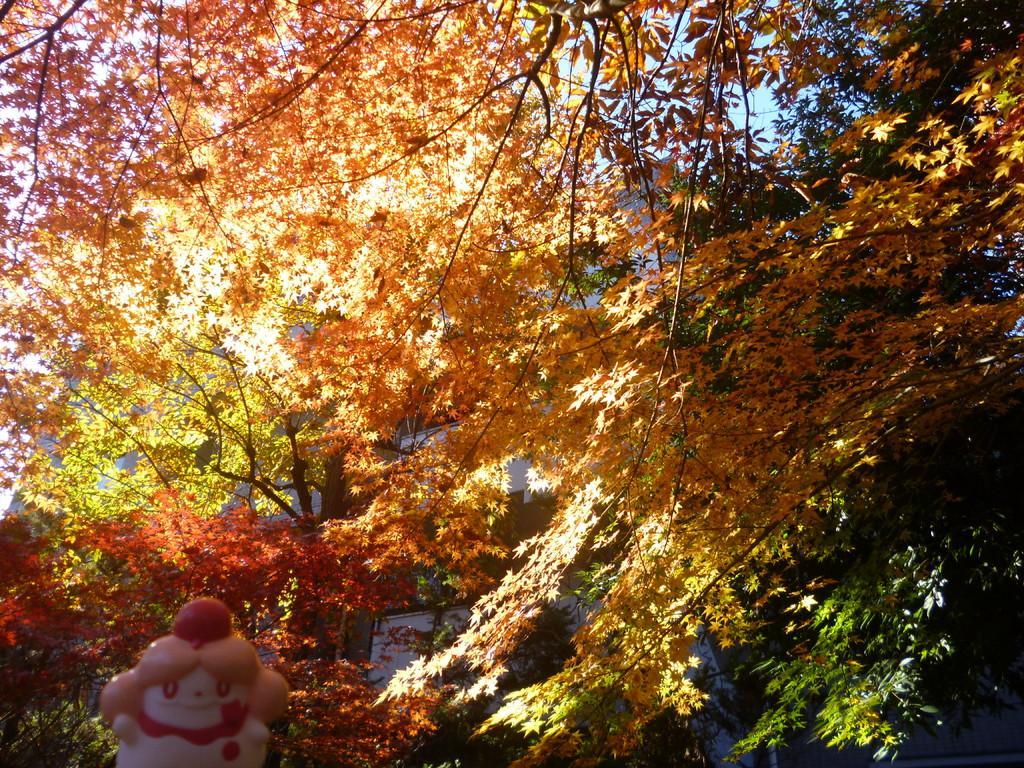In one or two sentences, can you explain what this image depicts? In this image I can see colorful tree and I can see a toy visible at the bottom. 